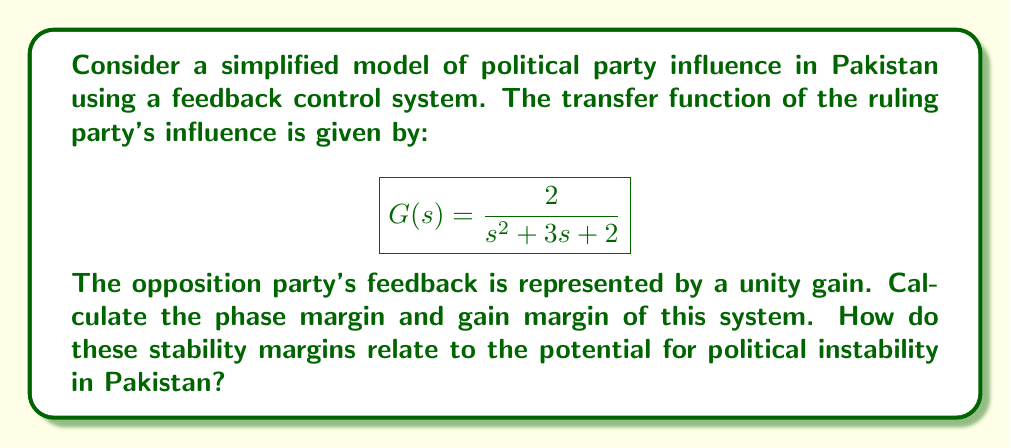Solve this math problem. To analyze the stability margins of this political influence model, we'll follow these steps:

1. Find the open-loop transfer function:
   $$L(s) = G(s) \cdot H(s) = \frac{2}{s^2 + 3s + 2} \cdot 1 = \frac{2}{s^2 + 3s + 2}$$

2. Calculate the phase margin:
   a. Find the gain crossover frequency $\omega_{gc}$ where $|L(j\omega)| = 1$:
      $$|L(j\omega)| = \left|\frac{2}{(j\omega)^2 + 3j\omega + 2}\right| = 1$$
      Solving this equation numerically, we get $\omega_{gc} \approx 0.765$ rad/s.

   b. Calculate the phase angle at $\omega_{gc}$:
      $$\angle L(j\omega_{gc}) = -\tan^{-1}\left(\frac{2\omega_{gc}}{2-\omega_{gc}^2}\right) - \tan^{-1}\left(\frac{3\omega_{gc}}{2-\omega_{gc}^2}\right)$$
      $$\angle L(j\omega_{gc}) \approx -126.9°$$

   c. Calculate the phase margin:
      $$\text{PM} = 180° + \angle L(j\omega_{gc}) \approx 53.1°$$

3. Calculate the gain margin:
   a. Find the phase crossover frequency $\omega_{pc}$ where $\angle L(j\omega) = -180°$:
      $$-180° = -\tan^{-1}\left(\frac{2\omega}{2-\omega^2}\right) - \tan^{-1}\left(\frac{3\omega}{2-\omega^2}\right)$$
      Solving this equation numerically, we get $\omega_{pc} \approx 1.414$ rad/s.

   b. Calculate the magnitude at $\omega_{pc}$:
      $$|L(j\omega_{pc})| = \left|\frac{2}{(j\omega_{pc})^2 + 3j\omega_{pc} + 2}\right| \approx 0.5$$

   c. Calculate the gain margin:
      $$\text{GM} = \frac{1}{|L(j\omega_{pc})|} \approx 2$$

In the context of Pakistan's political history, these stability margins can be interpreted as follows:

- The phase margin of 53.1° indicates a moderate level of stability in the political system. A larger phase margin would suggest a more stable system that can withstand greater perturbations.
- The gain margin of 2 suggests that the system can tolerate up to a doubling of the open-loop gain before becoming unstable. This implies some resilience in the political structure, but also indicates potential for instability if opposition influence grows too strong.

These margins provide insight into the robustness of Pakistan's political system against opposition influence and external disturbances, which could be related to historical events such as military coups, shifts in public opinion, or international pressures.
Answer: Phase Margin: 53.1°
Gain Margin: 2 (or 6.02 dB) 